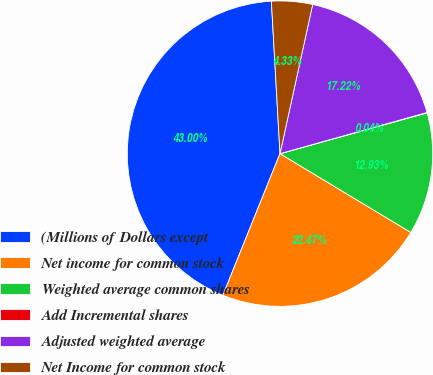Convert chart to OTSL. <chart><loc_0><loc_0><loc_500><loc_500><pie_chart><fcel>(Millions of Dollars except<fcel>Net income for common stock<fcel>Weighted average common shares<fcel>Add Incremental shares<fcel>Adjusted weighted average<fcel>Net Income for common stock<nl><fcel>43.0%<fcel>22.47%<fcel>12.93%<fcel>0.04%<fcel>17.22%<fcel>4.33%<nl></chart> 